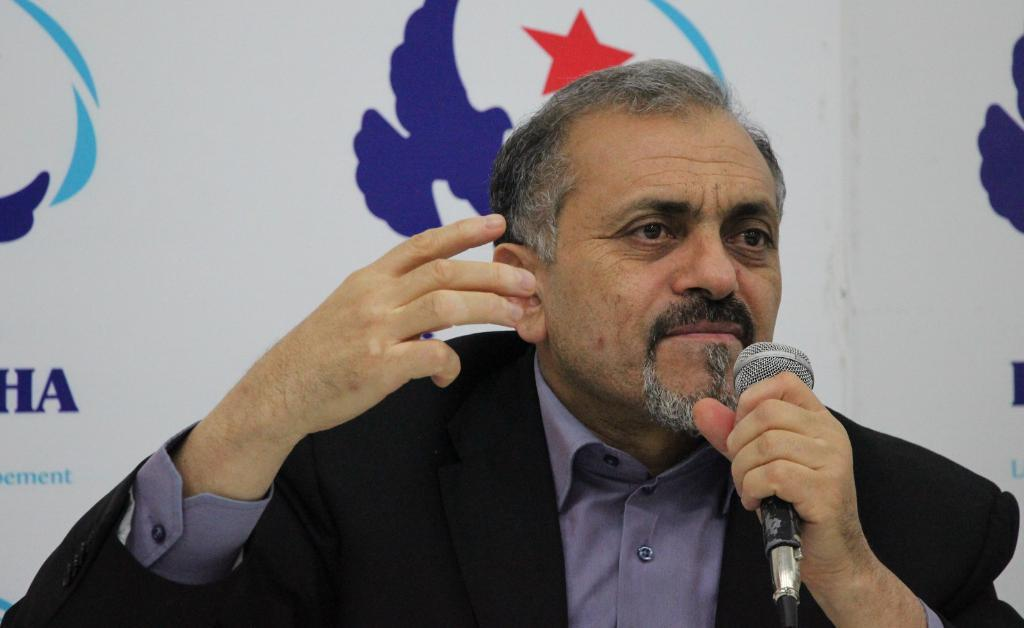Who is present in the image? There is a man in the image. What is the man holding in his hand? The man is holding a microphone in his hand. What type of clothing is the man wearing? The man is wearing a blazer. What can be seen in the background of the image? There is a banner in the background of the image. Is there a girl helping the man with the microphone in the image? There is no girl present in the image, and the man is not receiving help with the microphone. 